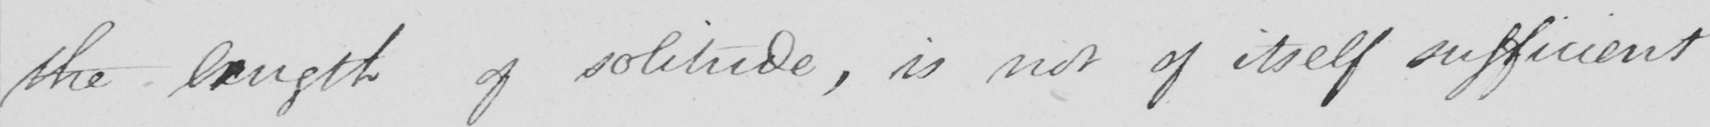What does this handwritten line say? the length of solitude , is not of itself sufficient 